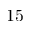Convert formula to latex. <formula><loc_0><loc_0><loc_500><loc_500>1 5</formula> 